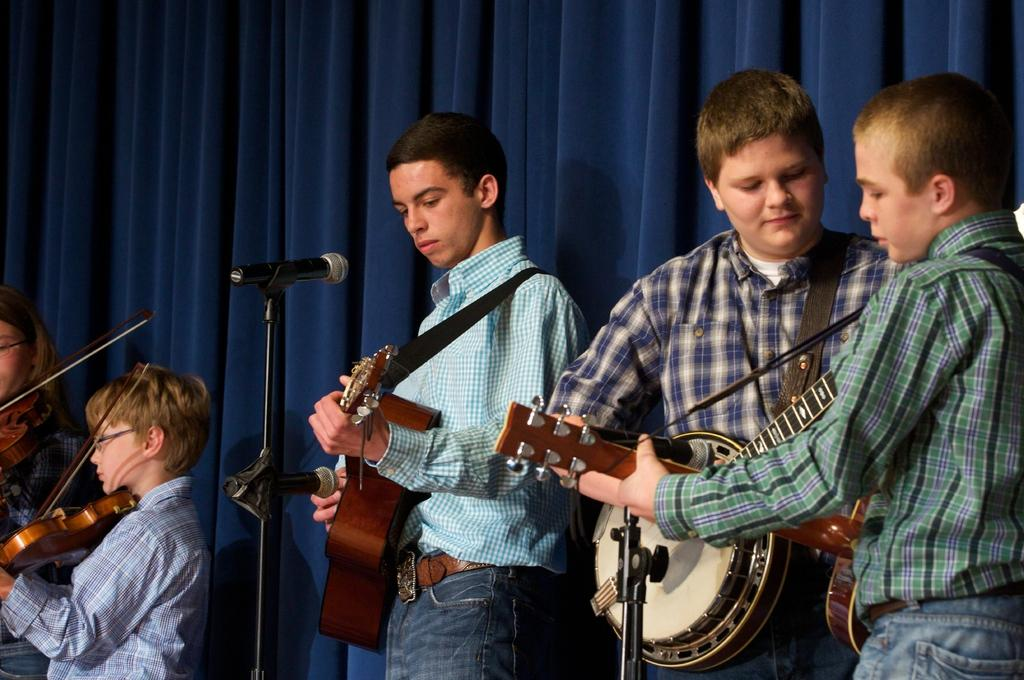How many people are present in the image? There are five persons in the image. What are the people in the image doing? Each person is holding a musical instrument. Can you describe any equipment related to sound in the image? Yes, there is a microphone in the image. What color is the curtain in the background of the image? There is a blue curtain in the background. What type of gate can be seen in the image? There is no gate present in the image. What kind of paper is being used by the musicians in the image? The image does not show any paper being used by the musicians; they are holding musical instruments. 